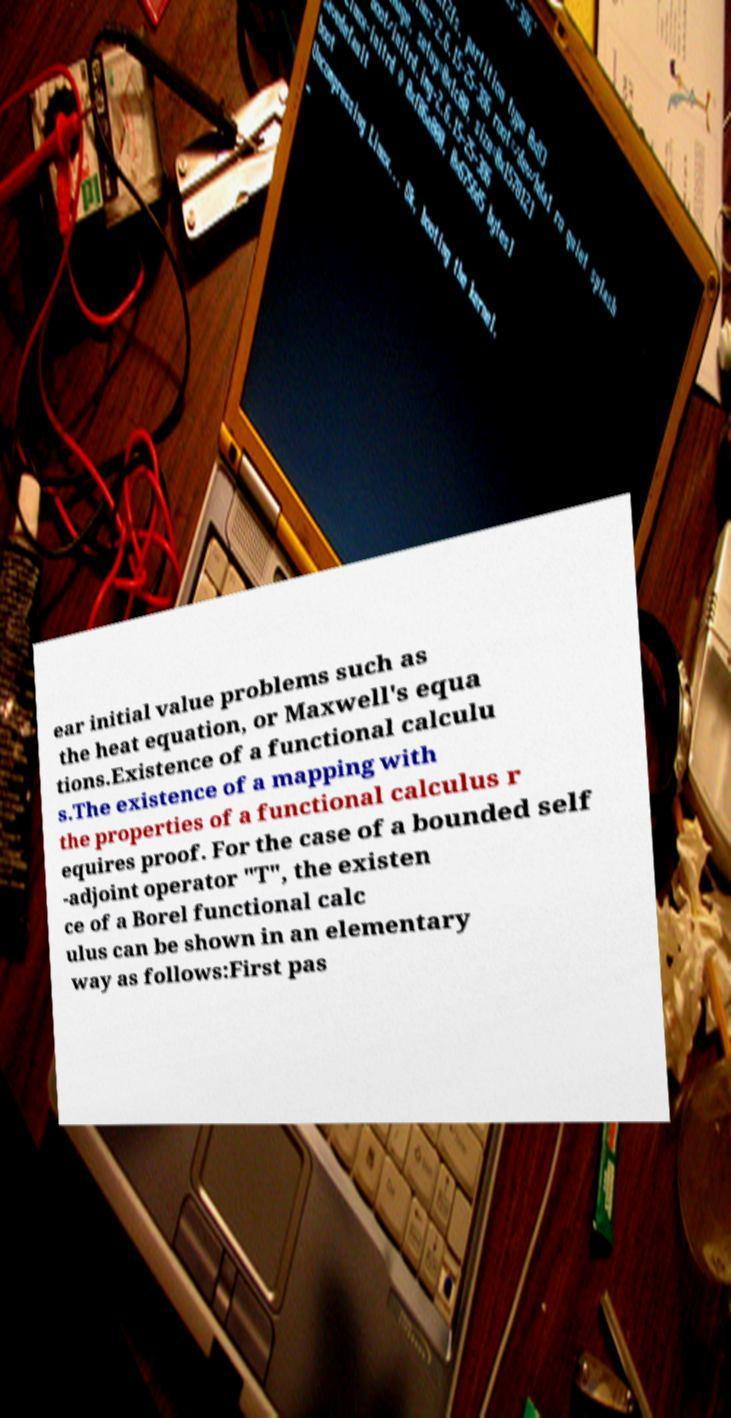Please read and relay the text visible in this image. What does it say? ear initial value problems such as the heat equation, or Maxwell's equa tions.Existence of a functional calculu s.The existence of a mapping with the properties of a functional calculus r equires proof. For the case of a bounded self -adjoint operator "T", the existen ce of a Borel functional calc ulus can be shown in an elementary way as follows:First pas 